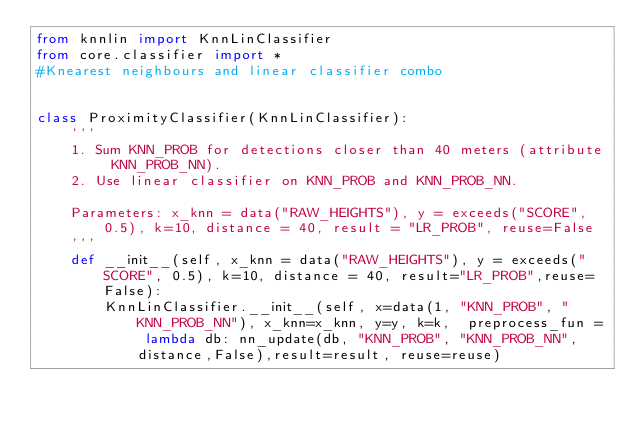Convert code to text. <code><loc_0><loc_0><loc_500><loc_500><_Python_>from knnlin import KnnLinClassifier
from core.classifier import *
#Knearest neighbours and linear classifier combo


class ProximityClassifier(KnnLinClassifier):
    '''
    1. Sum KNN_PROB for detections closer than 40 meters (attribute KNN_PROB_NN). 
    2. Use linear classifier on KNN_PROB and KNN_PROB_NN.

    Parameters: x_knn = data("RAW_HEIGHTS"), y = exceeds("SCORE", 0.5), k=10, distance = 40, result = "LR_PROB", reuse=False
    '''
    def __init__(self, x_knn = data("RAW_HEIGHTS"), y = exceeds("SCORE", 0.5), k=10, distance = 40, result="LR_PROB",reuse=False):
        KnnLinClassifier.__init__(self, x=data(1, "KNN_PROB", "KNN_PROB_NN"), x_knn=x_knn, y=y, k=k,  preprocess_fun = lambda db: nn_update(db, "KNN_PROB", "KNN_PROB_NN", distance,False),result=result, reuse=reuse)



</code> 